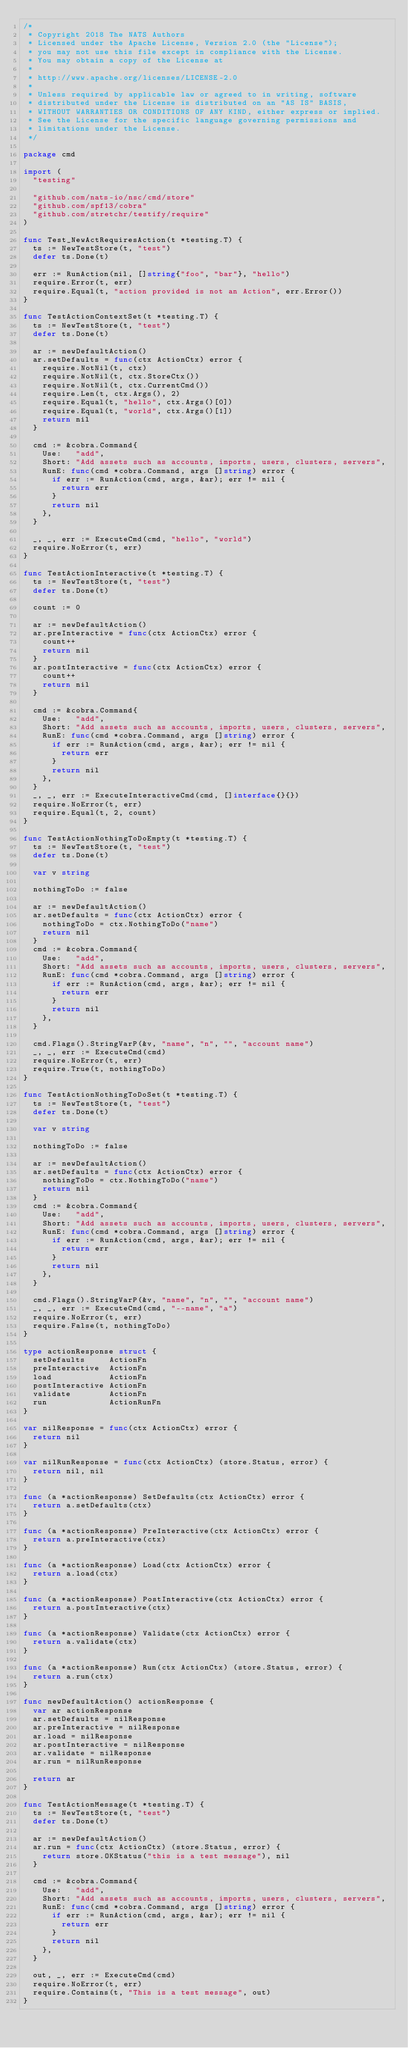Convert code to text. <code><loc_0><loc_0><loc_500><loc_500><_Go_>/*
 * Copyright 2018 The NATS Authors
 * Licensed under the Apache License, Version 2.0 (the "License");
 * you may not use this file except in compliance with the License.
 * You may obtain a copy of the License at
 *
 * http://www.apache.org/licenses/LICENSE-2.0
 *
 * Unless required by applicable law or agreed to in writing, software
 * distributed under the License is distributed on an "AS IS" BASIS,
 * WITHOUT WARRANTIES OR CONDITIONS OF ANY KIND, either express or implied.
 * See the License for the specific language governing permissions and
 * limitations under the License.
 */

package cmd

import (
	"testing"

	"github.com/nats-io/nsc/cmd/store"
	"github.com/spf13/cobra"
	"github.com/stretchr/testify/require"
)

func Test_NewActRequiresAction(t *testing.T) {
	ts := NewTestStore(t, "test")
	defer ts.Done(t)

	err := RunAction(nil, []string{"foo", "bar"}, "hello")
	require.Error(t, err)
	require.Equal(t, "action provided is not an Action", err.Error())
}

func TestActionContextSet(t *testing.T) {
	ts := NewTestStore(t, "test")
	defer ts.Done(t)

	ar := newDefaultAction()
	ar.setDefaults = func(ctx ActionCtx) error {
		require.NotNil(t, ctx)
		require.NotNil(t, ctx.StoreCtx())
		require.NotNil(t, ctx.CurrentCmd())
		require.Len(t, ctx.Args(), 2)
		require.Equal(t, "hello", ctx.Args()[0])
		require.Equal(t, "world", ctx.Args()[1])
		return nil
	}

	cmd := &cobra.Command{
		Use:   "add",
		Short: "Add assets such as accounts, imports, users, clusters, servers",
		RunE: func(cmd *cobra.Command, args []string) error {
			if err := RunAction(cmd, args, &ar); err != nil {
				return err
			}
			return nil
		},
	}

	_, _, err := ExecuteCmd(cmd, "hello", "world")
	require.NoError(t, err)
}

func TestActionInteractive(t *testing.T) {
	ts := NewTestStore(t, "test")
	defer ts.Done(t)

	count := 0

	ar := newDefaultAction()
	ar.preInteractive = func(ctx ActionCtx) error {
		count++
		return nil
	}
	ar.postInteractive = func(ctx ActionCtx) error {
		count++
		return nil
	}

	cmd := &cobra.Command{
		Use:   "add",
		Short: "Add assets such as accounts, imports, users, clusters, servers",
		RunE: func(cmd *cobra.Command, args []string) error {
			if err := RunAction(cmd, args, &ar); err != nil {
				return err
			}
			return nil
		},
	}
	_, _, err := ExecuteInteractiveCmd(cmd, []interface{}{})
	require.NoError(t, err)
	require.Equal(t, 2, count)
}

func TestActionNothingToDoEmpty(t *testing.T) {
	ts := NewTestStore(t, "test")
	defer ts.Done(t)

	var v string

	nothingToDo := false

	ar := newDefaultAction()
	ar.setDefaults = func(ctx ActionCtx) error {
		nothingToDo = ctx.NothingToDo("name")
		return nil
	}
	cmd := &cobra.Command{
		Use:   "add",
		Short: "Add assets such as accounts, imports, users, clusters, servers",
		RunE: func(cmd *cobra.Command, args []string) error {
			if err := RunAction(cmd, args, &ar); err != nil {
				return err
			}
			return nil
		},
	}

	cmd.Flags().StringVarP(&v, "name", "n", "", "account name")
	_, _, err := ExecuteCmd(cmd)
	require.NoError(t, err)
	require.True(t, nothingToDo)
}

func TestActionNothingToDoSet(t *testing.T) {
	ts := NewTestStore(t, "test")
	defer ts.Done(t)

	var v string

	nothingToDo := false

	ar := newDefaultAction()
	ar.setDefaults = func(ctx ActionCtx) error {
		nothingToDo = ctx.NothingToDo("name")
		return nil
	}
	cmd := &cobra.Command{
		Use:   "add",
		Short: "Add assets such as accounts, imports, users, clusters, servers",
		RunE: func(cmd *cobra.Command, args []string) error {
			if err := RunAction(cmd, args, &ar); err != nil {
				return err
			}
			return nil
		},
	}

	cmd.Flags().StringVarP(&v, "name", "n", "", "account name")
	_, _, err := ExecuteCmd(cmd, "--name", "a")
	require.NoError(t, err)
	require.False(t, nothingToDo)
}

type actionResponse struct {
	setDefaults     ActionFn
	preInteractive  ActionFn
	load            ActionFn
	postInteractive ActionFn
	validate        ActionFn
	run             ActionRunFn
}

var nilResponse = func(ctx ActionCtx) error {
	return nil
}

var nilRunResponse = func(ctx ActionCtx) (store.Status, error) {
	return nil, nil
}

func (a *actionResponse) SetDefaults(ctx ActionCtx) error {
	return a.setDefaults(ctx)
}

func (a *actionResponse) PreInteractive(ctx ActionCtx) error {
	return a.preInteractive(ctx)
}

func (a *actionResponse) Load(ctx ActionCtx) error {
	return a.load(ctx)
}

func (a *actionResponse) PostInteractive(ctx ActionCtx) error {
	return a.postInteractive(ctx)
}

func (a *actionResponse) Validate(ctx ActionCtx) error {
	return a.validate(ctx)
}

func (a *actionResponse) Run(ctx ActionCtx) (store.Status, error) {
	return a.run(ctx)
}

func newDefaultAction() actionResponse {
	var ar actionResponse
	ar.setDefaults = nilResponse
	ar.preInteractive = nilResponse
	ar.load = nilResponse
	ar.postInteractive = nilResponse
	ar.validate = nilResponse
	ar.run = nilRunResponse

	return ar
}

func TestActionMessage(t *testing.T) {
	ts := NewTestStore(t, "test")
	defer ts.Done(t)

	ar := newDefaultAction()
	ar.run = func(ctx ActionCtx) (store.Status, error) {
		return store.OKStatus("this is a test message"), nil
	}

	cmd := &cobra.Command{
		Use:   "add",
		Short: "Add assets such as accounts, imports, users, clusters, servers",
		RunE: func(cmd *cobra.Command, args []string) error {
			if err := RunAction(cmd, args, &ar); err != nil {
				return err
			}
			return nil
		},
	}

	out, _, err := ExecuteCmd(cmd)
	require.NoError(t, err)
	require.Contains(t, "This is a test message", out)
}
</code> 